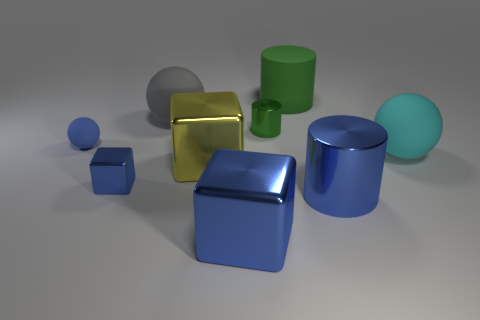Subtract all yellow cylinders. How many blue cubes are left? 2 Subtract all blue shiny cubes. How many cubes are left? 1 Add 1 small purple objects. How many objects exist? 10 Subtract 1 cylinders. How many cylinders are left? 2 Subtract all small cyan cylinders. Subtract all metallic cylinders. How many objects are left? 7 Add 7 small objects. How many small objects are left? 10 Add 7 big yellow shiny blocks. How many big yellow shiny blocks exist? 8 Subtract 1 green cylinders. How many objects are left? 8 Subtract all cubes. How many objects are left? 6 Subtract all purple balls. Subtract all blue cubes. How many balls are left? 3 